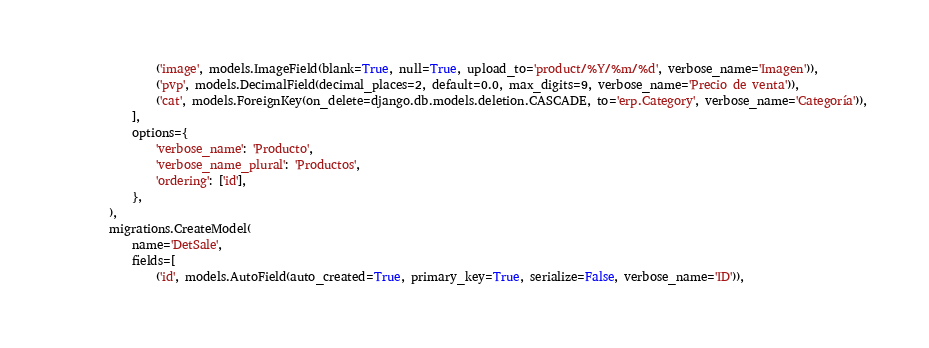<code> <loc_0><loc_0><loc_500><loc_500><_Python_>                ('image', models.ImageField(blank=True, null=True, upload_to='product/%Y/%m/%d', verbose_name='Imagen')),
                ('pvp', models.DecimalField(decimal_places=2, default=0.0, max_digits=9, verbose_name='Precio de venta')),
                ('cat', models.ForeignKey(on_delete=django.db.models.deletion.CASCADE, to='erp.Category', verbose_name='Categoría')),
            ],
            options={
                'verbose_name': 'Producto',
                'verbose_name_plural': 'Productos',
                'ordering': ['id'],
            },
        ),
        migrations.CreateModel(
            name='DetSale',
            fields=[
                ('id', models.AutoField(auto_created=True, primary_key=True, serialize=False, verbose_name='ID')),</code> 